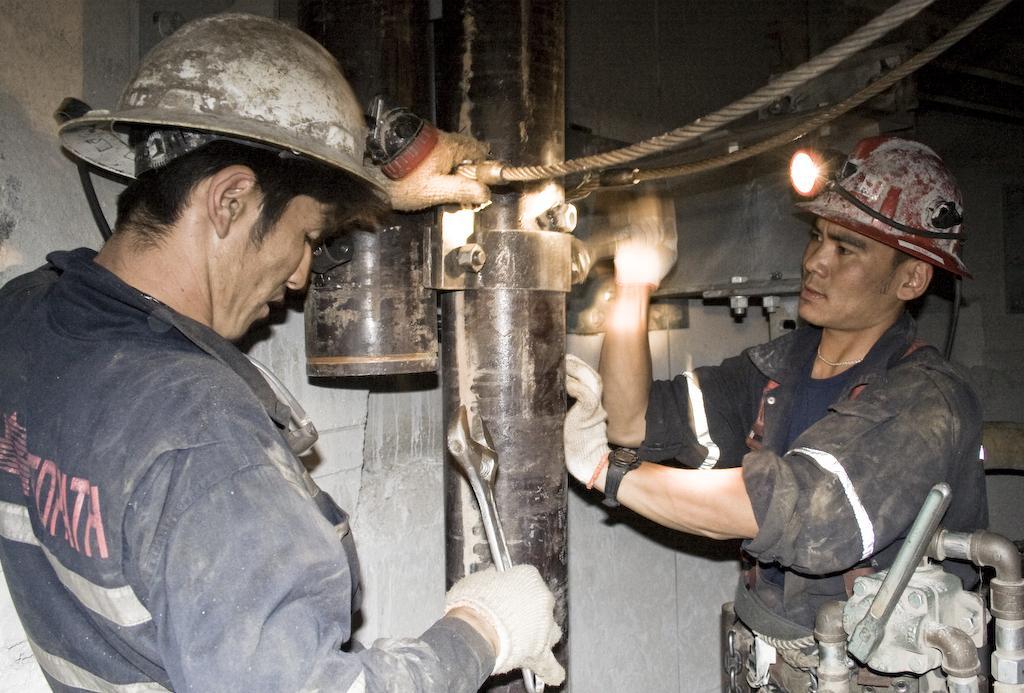In one or two sentences, can you explain what this image depicts? In this image there are two persons wearing hi vis jackets and helmets and holding some tools in their hands, the two persons are working on a metal rod. 